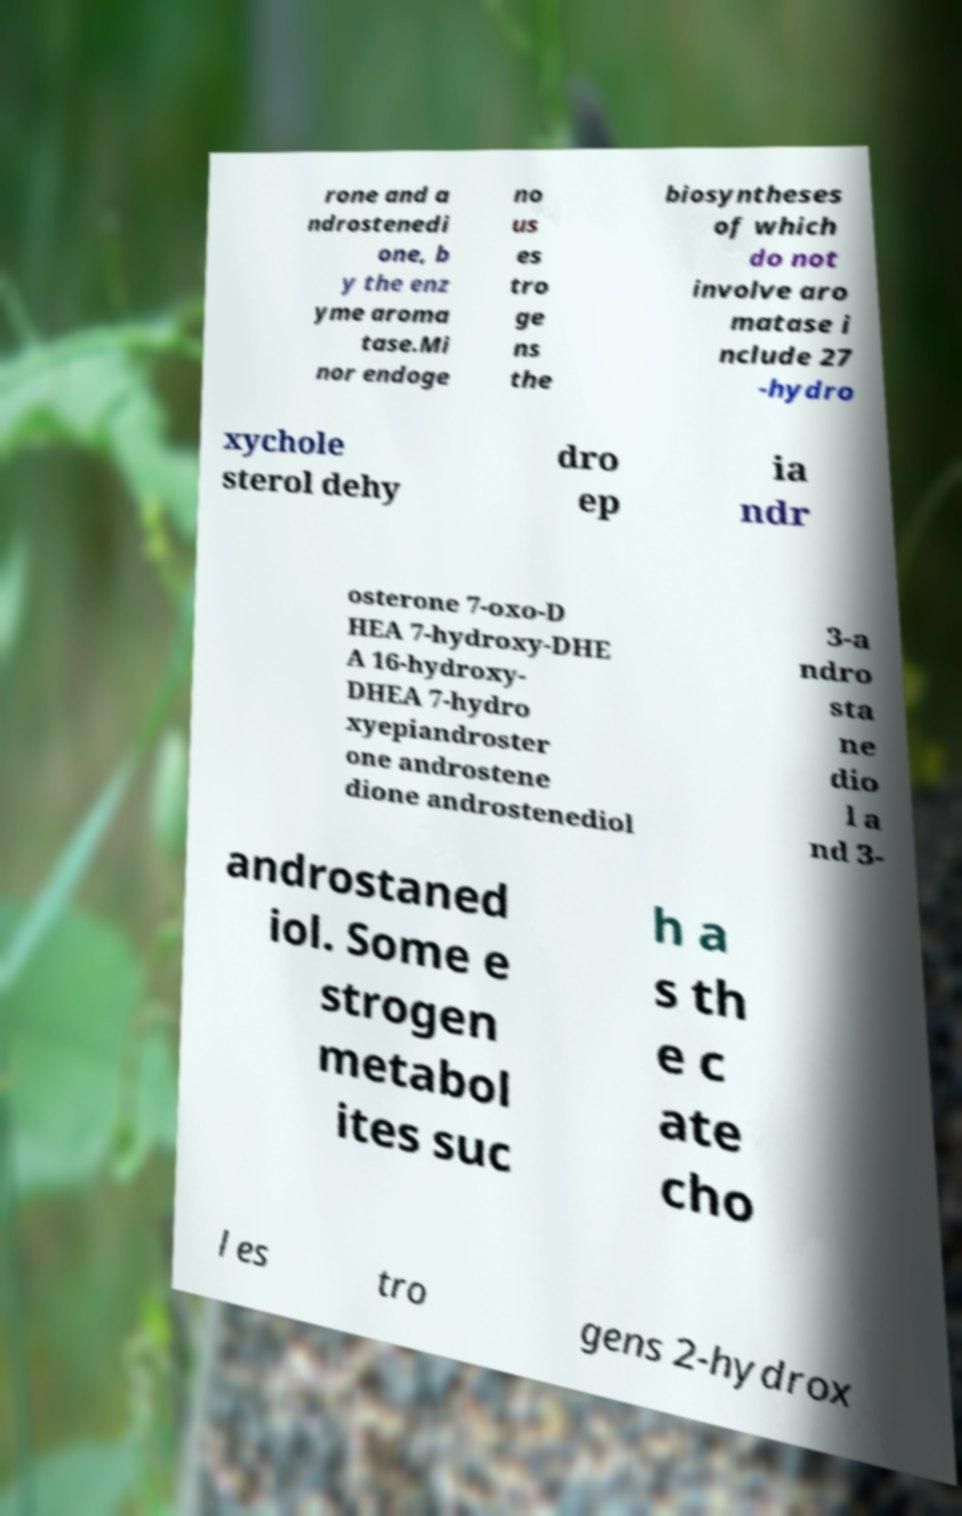I need the written content from this picture converted into text. Can you do that? rone and a ndrostenedi one, b y the enz yme aroma tase.Mi nor endoge no us es tro ge ns the biosyntheses of which do not involve aro matase i nclude 27 -hydro xychole sterol dehy dro ep ia ndr osterone 7-oxo-D HEA 7-hydroxy-DHE A 16-hydroxy- DHEA 7-hydro xyepiandroster one androstene dione androstenediol 3-a ndro sta ne dio l a nd 3- androstaned iol. Some e strogen metabol ites suc h a s th e c ate cho l es tro gens 2-hydrox 